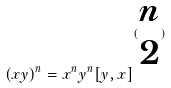<formula> <loc_0><loc_0><loc_500><loc_500>( x y ) ^ { n } = x ^ { n } y ^ { n } [ y , x ] ^ { ( \begin{matrix} n \\ 2 \end{matrix} ) }</formula> 